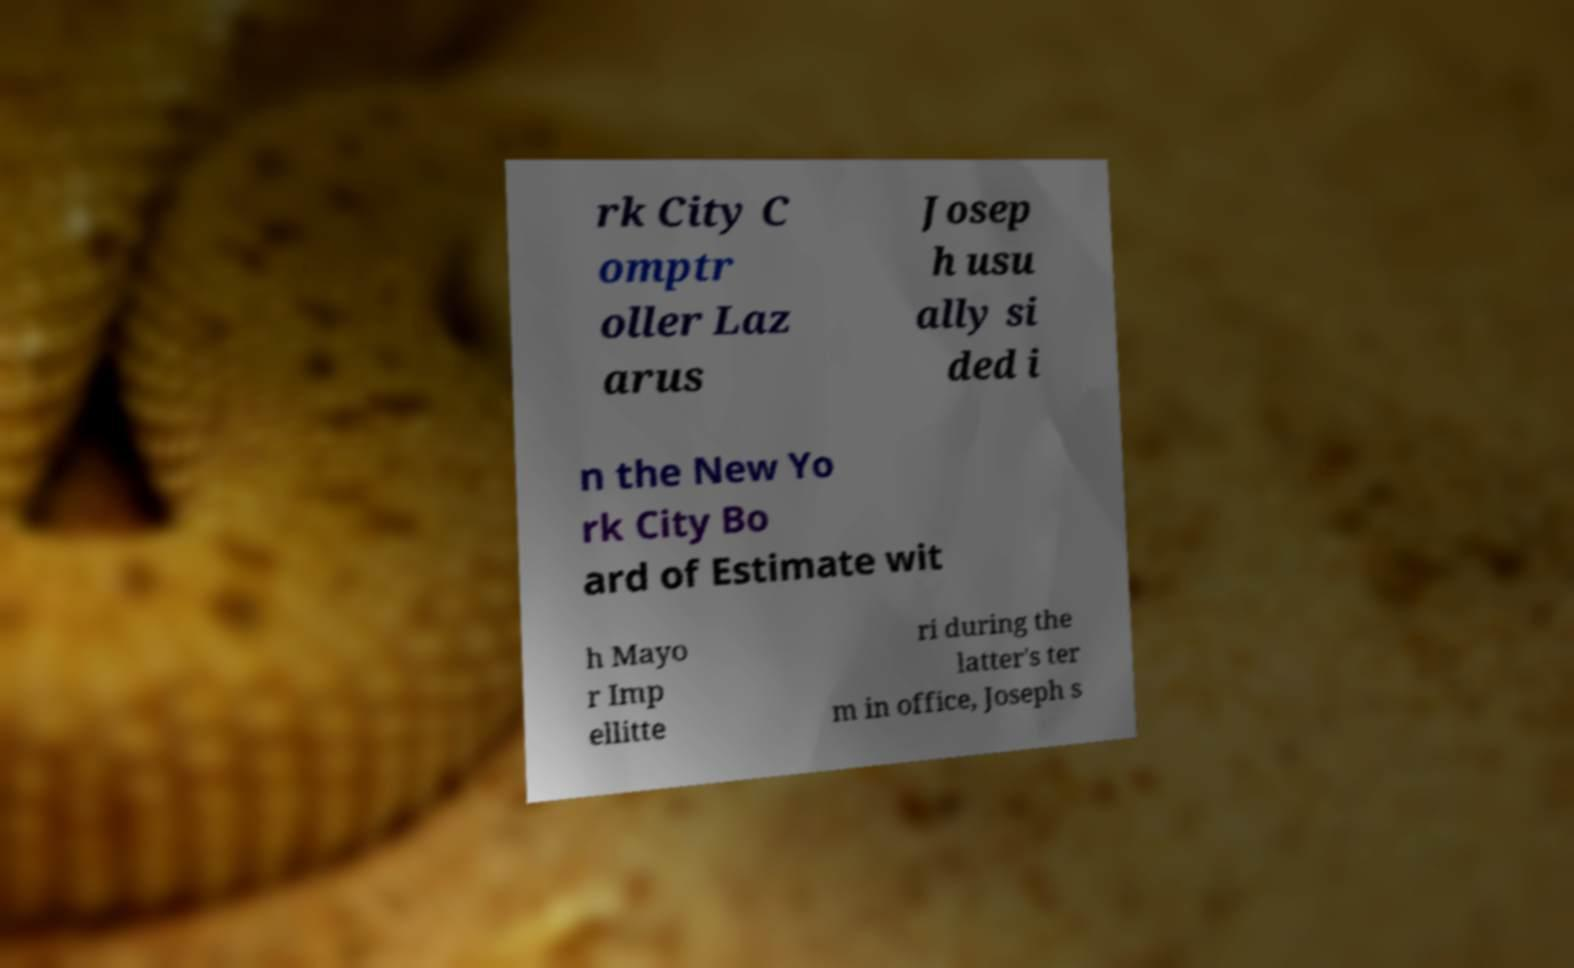Can you accurately transcribe the text from the provided image for me? rk City C omptr oller Laz arus Josep h usu ally si ded i n the New Yo rk City Bo ard of Estimate wit h Mayo r Imp ellitte ri during the latter's ter m in office, Joseph s 